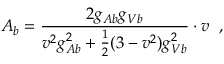<formula> <loc_0><loc_0><loc_500><loc_500>A _ { b } = \frac { 2 g _ { A b } g _ { V b } } { v ^ { 2 } g _ { A b } ^ { 2 } + \frac { 1 } { 2 } ( 3 - v ^ { 2 } ) g _ { V b } ^ { 2 } } \cdot v \, ,</formula> 